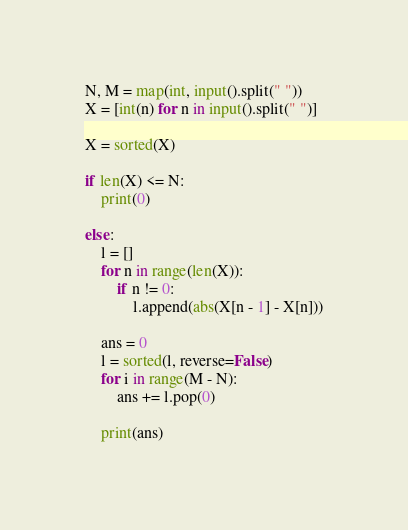Convert code to text. <code><loc_0><loc_0><loc_500><loc_500><_Python_>N, M = map(int, input().split(" "))
X = [int(n) for n in input().split(" ")]

X = sorted(X)

if len(X) <= N:
	print(0)

else:
	l = []
	for n in range(len(X)):
		if n != 0:
			l.append(abs(X[n - 1] - X[n]))

	ans = 0
	l = sorted(l, reverse=False)
	for i in range(M - N):
		ans += l.pop(0)

	print(ans)</code> 